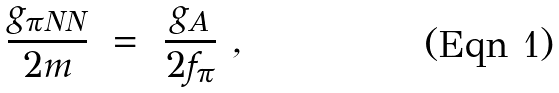Convert formula to latex. <formula><loc_0><loc_0><loc_500><loc_500>\frac { g _ { \pi N N } } { 2 m } \ = \ \frac { g _ { A } } { 2 f _ { \pi } } \ ,</formula> 